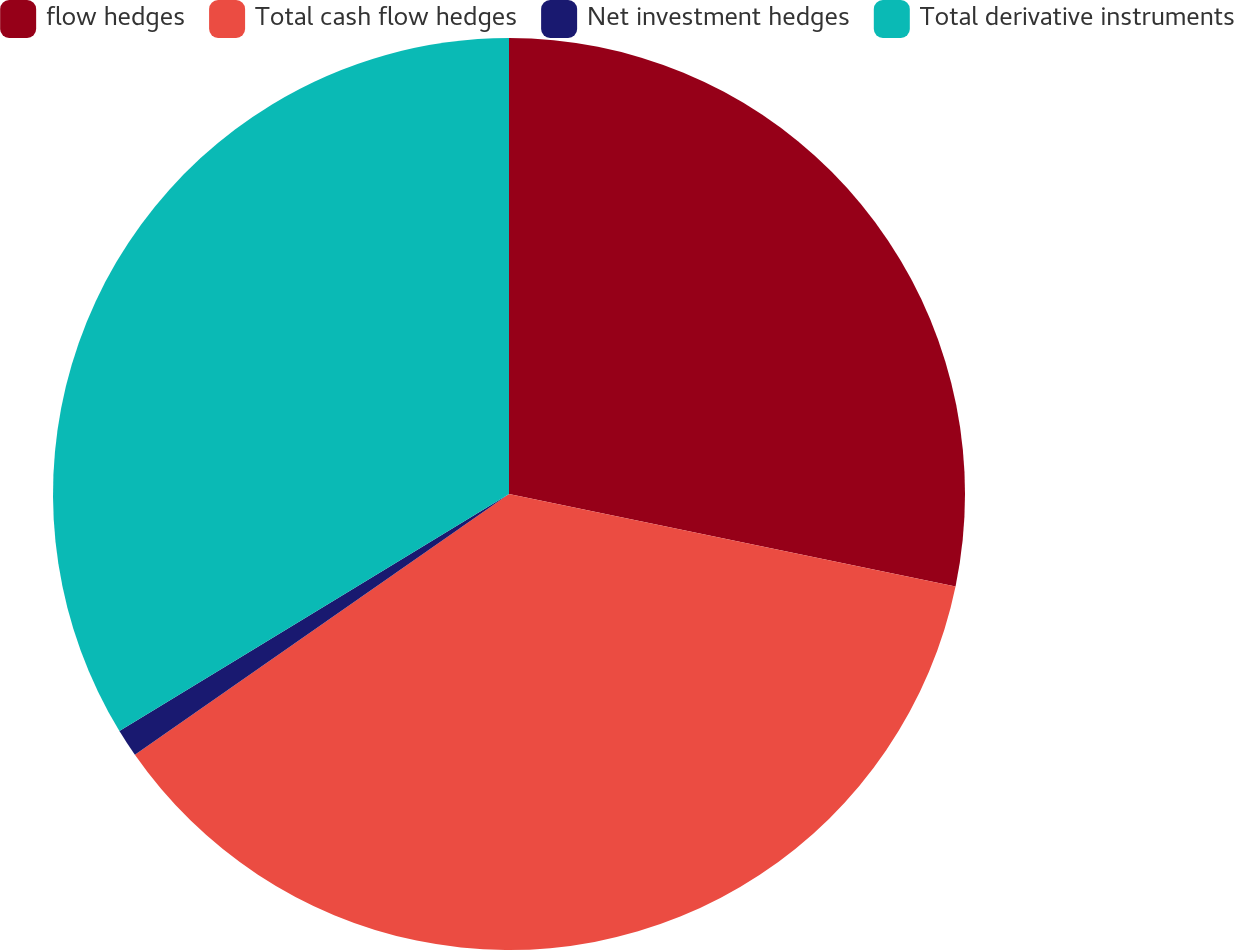<chart> <loc_0><loc_0><loc_500><loc_500><pie_chart><fcel>flow hedges<fcel>Total cash flow hedges<fcel>Net investment hedges<fcel>Total derivative instruments<nl><fcel>28.25%<fcel>37.07%<fcel>0.99%<fcel>33.7%<nl></chart> 